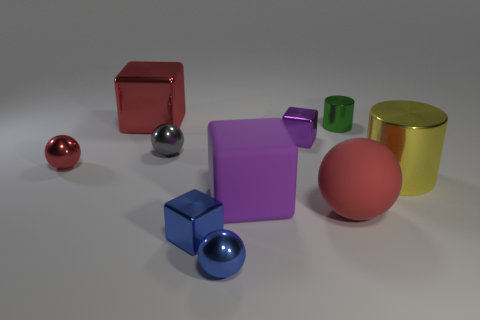Is the material of the small green cylinder the same as the small red thing? While both the small green cylinder and the small red object appear to have a smooth, possibly metallic finish, without additional information it's challenging to ascertain if they are made of exactly the same material. They could have similar properties but still be composed of different substances or blends. 